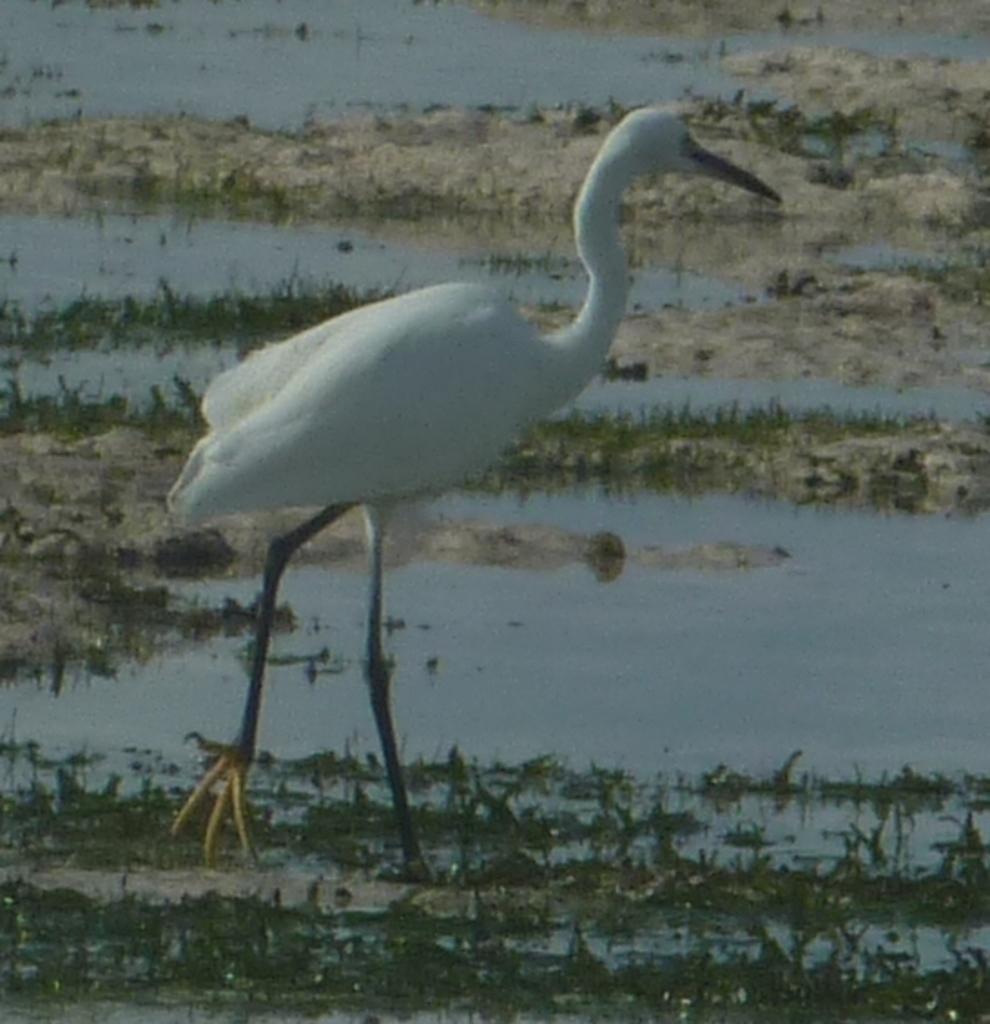Can you describe this image briefly? In this image we can see a bird. We can also see the grass, sand and also the water. 